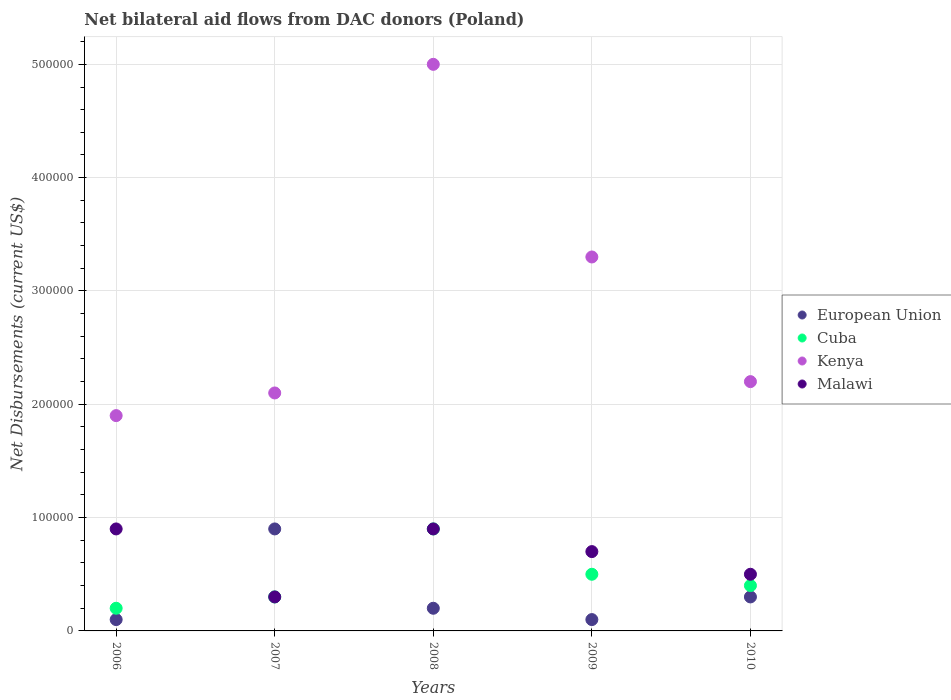Across all years, what is the maximum net bilateral aid flows in European Union?
Give a very brief answer. 9.00e+04. Across all years, what is the minimum net bilateral aid flows in Malawi?
Offer a terse response. 3.00e+04. What is the difference between the net bilateral aid flows in Malawi in 2007 and that in 2010?
Offer a very short reply. -2.00e+04. What is the difference between the net bilateral aid flows in European Union in 2007 and the net bilateral aid flows in Cuba in 2008?
Your answer should be compact. 0. What is the average net bilateral aid flows in European Union per year?
Keep it short and to the point. 3.20e+04. In how many years, is the net bilateral aid flows in Kenya greater than 40000 US$?
Your answer should be compact. 5. What is the ratio of the net bilateral aid flows in Kenya in 2007 to that in 2008?
Provide a succinct answer. 0.42. Is the net bilateral aid flows in Malawi in 2008 less than that in 2009?
Offer a terse response. No. What is the difference between the highest and the second highest net bilateral aid flows in Malawi?
Keep it short and to the point. 0. What is the difference between the highest and the lowest net bilateral aid flows in Malawi?
Provide a short and direct response. 6.00e+04. In how many years, is the net bilateral aid flows in European Union greater than the average net bilateral aid flows in European Union taken over all years?
Provide a short and direct response. 1. Does the net bilateral aid flows in Cuba monotonically increase over the years?
Provide a short and direct response. No. Is the net bilateral aid flows in Kenya strictly less than the net bilateral aid flows in Malawi over the years?
Provide a succinct answer. No. What is the difference between two consecutive major ticks on the Y-axis?
Keep it short and to the point. 1.00e+05. Does the graph contain any zero values?
Your response must be concise. No. How many legend labels are there?
Your answer should be compact. 4. How are the legend labels stacked?
Your response must be concise. Vertical. What is the title of the graph?
Offer a terse response. Net bilateral aid flows from DAC donors (Poland). Does "Hong Kong" appear as one of the legend labels in the graph?
Provide a succinct answer. No. What is the label or title of the X-axis?
Your answer should be compact. Years. What is the label or title of the Y-axis?
Offer a terse response. Net Disbursements (current US$). What is the Net Disbursements (current US$) in Cuba in 2006?
Offer a terse response. 2.00e+04. What is the Net Disbursements (current US$) of European Union in 2007?
Provide a short and direct response. 9.00e+04. What is the Net Disbursements (current US$) in Kenya in 2007?
Your response must be concise. 2.10e+05. What is the Net Disbursements (current US$) in European Union in 2008?
Your answer should be compact. 2.00e+04. What is the Net Disbursements (current US$) of Kenya in 2008?
Give a very brief answer. 5.00e+05. What is the Net Disbursements (current US$) of Malawi in 2008?
Provide a short and direct response. 9.00e+04. What is the Net Disbursements (current US$) in Cuba in 2009?
Offer a very short reply. 5.00e+04. What is the Net Disbursements (current US$) in Kenya in 2009?
Ensure brevity in your answer.  3.30e+05. What is the Net Disbursements (current US$) in Malawi in 2009?
Ensure brevity in your answer.  7.00e+04. What is the Net Disbursements (current US$) of Malawi in 2010?
Provide a succinct answer. 5.00e+04. Across all years, what is the maximum Net Disbursements (current US$) in European Union?
Your response must be concise. 9.00e+04. Across all years, what is the maximum Net Disbursements (current US$) in Cuba?
Offer a very short reply. 9.00e+04. Across all years, what is the maximum Net Disbursements (current US$) of Kenya?
Offer a terse response. 5.00e+05. Across all years, what is the minimum Net Disbursements (current US$) of European Union?
Keep it short and to the point. 10000. Across all years, what is the minimum Net Disbursements (current US$) in Cuba?
Ensure brevity in your answer.  2.00e+04. Across all years, what is the minimum Net Disbursements (current US$) in Kenya?
Your answer should be very brief. 1.90e+05. What is the total Net Disbursements (current US$) in Cuba in the graph?
Your answer should be very brief. 2.30e+05. What is the total Net Disbursements (current US$) of Kenya in the graph?
Offer a terse response. 1.45e+06. What is the total Net Disbursements (current US$) of Malawi in the graph?
Your answer should be compact. 3.30e+05. What is the difference between the Net Disbursements (current US$) in Cuba in 2006 and that in 2007?
Provide a short and direct response. -10000. What is the difference between the Net Disbursements (current US$) of Kenya in 2006 and that in 2007?
Your answer should be compact. -2.00e+04. What is the difference between the Net Disbursements (current US$) of Cuba in 2006 and that in 2008?
Provide a succinct answer. -7.00e+04. What is the difference between the Net Disbursements (current US$) in Kenya in 2006 and that in 2008?
Your response must be concise. -3.10e+05. What is the difference between the Net Disbursements (current US$) of Malawi in 2006 and that in 2008?
Provide a short and direct response. 0. What is the difference between the Net Disbursements (current US$) in European Union in 2006 and that in 2009?
Offer a terse response. 0. What is the difference between the Net Disbursements (current US$) in Cuba in 2006 and that in 2009?
Your answer should be very brief. -3.00e+04. What is the difference between the Net Disbursements (current US$) in Cuba in 2006 and that in 2010?
Make the answer very short. -2.00e+04. What is the difference between the Net Disbursements (current US$) of Cuba in 2007 and that in 2008?
Give a very brief answer. -6.00e+04. What is the difference between the Net Disbursements (current US$) of Malawi in 2007 and that in 2008?
Make the answer very short. -6.00e+04. What is the difference between the Net Disbursements (current US$) of European Union in 2007 and that in 2009?
Your answer should be compact. 8.00e+04. What is the difference between the Net Disbursements (current US$) of Cuba in 2007 and that in 2009?
Give a very brief answer. -2.00e+04. What is the difference between the Net Disbursements (current US$) in Malawi in 2007 and that in 2009?
Offer a very short reply. -4.00e+04. What is the difference between the Net Disbursements (current US$) in Kenya in 2007 and that in 2010?
Your answer should be very brief. -10000. What is the difference between the Net Disbursements (current US$) in Malawi in 2007 and that in 2010?
Your response must be concise. -2.00e+04. What is the difference between the Net Disbursements (current US$) of Cuba in 2008 and that in 2009?
Your answer should be very brief. 4.00e+04. What is the difference between the Net Disbursements (current US$) in Cuba in 2008 and that in 2010?
Make the answer very short. 5.00e+04. What is the difference between the Net Disbursements (current US$) of Cuba in 2009 and that in 2010?
Provide a short and direct response. 10000. What is the difference between the Net Disbursements (current US$) in Kenya in 2009 and that in 2010?
Offer a very short reply. 1.10e+05. What is the difference between the Net Disbursements (current US$) in European Union in 2006 and the Net Disbursements (current US$) in Kenya in 2007?
Your answer should be very brief. -2.00e+05. What is the difference between the Net Disbursements (current US$) of European Union in 2006 and the Net Disbursements (current US$) of Malawi in 2007?
Your answer should be compact. -2.00e+04. What is the difference between the Net Disbursements (current US$) of Cuba in 2006 and the Net Disbursements (current US$) of Kenya in 2007?
Make the answer very short. -1.90e+05. What is the difference between the Net Disbursements (current US$) of Kenya in 2006 and the Net Disbursements (current US$) of Malawi in 2007?
Your answer should be compact. 1.60e+05. What is the difference between the Net Disbursements (current US$) of European Union in 2006 and the Net Disbursements (current US$) of Kenya in 2008?
Provide a succinct answer. -4.90e+05. What is the difference between the Net Disbursements (current US$) in European Union in 2006 and the Net Disbursements (current US$) in Malawi in 2008?
Offer a very short reply. -8.00e+04. What is the difference between the Net Disbursements (current US$) in Cuba in 2006 and the Net Disbursements (current US$) in Kenya in 2008?
Make the answer very short. -4.80e+05. What is the difference between the Net Disbursements (current US$) in Kenya in 2006 and the Net Disbursements (current US$) in Malawi in 2008?
Ensure brevity in your answer.  1.00e+05. What is the difference between the Net Disbursements (current US$) of European Union in 2006 and the Net Disbursements (current US$) of Cuba in 2009?
Provide a succinct answer. -4.00e+04. What is the difference between the Net Disbursements (current US$) in European Union in 2006 and the Net Disbursements (current US$) in Kenya in 2009?
Your response must be concise. -3.20e+05. What is the difference between the Net Disbursements (current US$) in Cuba in 2006 and the Net Disbursements (current US$) in Kenya in 2009?
Ensure brevity in your answer.  -3.10e+05. What is the difference between the Net Disbursements (current US$) of Cuba in 2006 and the Net Disbursements (current US$) of Malawi in 2009?
Provide a succinct answer. -5.00e+04. What is the difference between the Net Disbursements (current US$) in Kenya in 2006 and the Net Disbursements (current US$) in Malawi in 2009?
Make the answer very short. 1.20e+05. What is the difference between the Net Disbursements (current US$) of European Union in 2006 and the Net Disbursements (current US$) of Cuba in 2010?
Give a very brief answer. -3.00e+04. What is the difference between the Net Disbursements (current US$) of European Union in 2006 and the Net Disbursements (current US$) of Kenya in 2010?
Give a very brief answer. -2.10e+05. What is the difference between the Net Disbursements (current US$) of Cuba in 2006 and the Net Disbursements (current US$) of Kenya in 2010?
Offer a very short reply. -2.00e+05. What is the difference between the Net Disbursements (current US$) of Cuba in 2006 and the Net Disbursements (current US$) of Malawi in 2010?
Keep it short and to the point. -3.00e+04. What is the difference between the Net Disbursements (current US$) of Kenya in 2006 and the Net Disbursements (current US$) of Malawi in 2010?
Provide a succinct answer. 1.40e+05. What is the difference between the Net Disbursements (current US$) in European Union in 2007 and the Net Disbursements (current US$) in Cuba in 2008?
Provide a short and direct response. 0. What is the difference between the Net Disbursements (current US$) in European Union in 2007 and the Net Disbursements (current US$) in Kenya in 2008?
Keep it short and to the point. -4.10e+05. What is the difference between the Net Disbursements (current US$) in Cuba in 2007 and the Net Disbursements (current US$) in Kenya in 2008?
Offer a very short reply. -4.70e+05. What is the difference between the Net Disbursements (current US$) in Cuba in 2007 and the Net Disbursements (current US$) in Malawi in 2008?
Keep it short and to the point. -6.00e+04. What is the difference between the Net Disbursements (current US$) of Kenya in 2007 and the Net Disbursements (current US$) of Malawi in 2008?
Keep it short and to the point. 1.20e+05. What is the difference between the Net Disbursements (current US$) in Cuba in 2007 and the Net Disbursements (current US$) in Malawi in 2009?
Your response must be concise. -4.00e+04. What is the difference between the Net Disbursements (current US$) in European Union in 2007 and the Net Disbursements (current US$) in Kenya in 2010?
Your answer should be very brief. -1.30e+05. What is the difference between the Net Disbursements (current US$) of Cuba in 2007 and the Net Disbursements (current US$) of Malawi in 2010?
Your answer should be compact. -2.00e+04. What is the difference between the Net Disbursements (current US$) in Kenya in 2007 and the Net Disbursements (current US$) in Malawi in 2010?
Your answer should be compact. 1.60e+05. What is the difference between the Net Disbursements (current US$) of European Union in 2008 and the Net Disbursements (current US$) of Kenya in 2009?
Make the answer very short. -3.10e+05. What is the difference between the Net Disbursements (current US$) of European Union in 2008 and the Net Disbursements (current US$) of Malawi in 2009?
Provide a succinct answer. -5.00e+04. What is the difference between the Net Disbursements (current US$) of Kenya in 2008 and the Net Disbursements (current US$) of Malawi in 2009?
Give a very brief answer. 4.30e+05. What is the difference between the Net Disbursements (current US$) of European Union in 2008 and the Net Disbursements (current US$) of Kenya in 2010?
Ensure brevity in your answer.  -2.00e+05. What is the difference between the Net Disbursements (current US$) in European Union in 2008 and the Net Disbursements (current US$) in Malawi in 2010?
Give a very brief answer. -3.00e+04. What is the difference between the Net Disbursements (current US$) in Cuba in 2008 and the Net Disbursements (current US$) in Malawi in 2010?
Give a very brief answer. 4.00e+04. What is the difference between the Net Disbursements (current US$) of European Union in 2009 and the Net Disbursements (current US$) of Cuba in 2010?
Your response must be concise. -3.00e+04. What is the difference between the Net Disbursements (current US$) in Cuba in 2009 and the Net Disbursements (current US$) in Malawi in 2010?
Your answer should be very brief. 0. What is the average Net Disbursements (current US$) of European Union per year?
Your answer should be very brief. 3.20e+04. What is the average Net Disbursements (current US$) of Cuba per year?
Make the answer very short. 4.60e+04. What is the average Net Disbursements (current US$) of Malawi per year?
Your response must be concise. 6.60e+04. In the year 2006, what is the difference between the Net Disbursements (current US$) of European Union and Net Disbursements (current US$) of Kenya?
Ensure brevity in your answer.  -1.80e+05. In the year 2006, what is the difference between the Net Disbursements (current US$) of European Union and Net Disbursements (current US$) of Malawi?
Ensure brevity in your answer.  -8.00e+04. In the year 2006, what is the difference between the Net Disbursements (current US$) in Kenya and Net Disbursements (current US$) in Malawi?
Your answer should be very brief. 1.00e+05. In the year 2007, what is the difference between the Net Disbursements (current US$) in European Union and Net Disbursements (current US$) in Kenya?
Offer a terse response. -1.20e+05. In the year 2007, what is the difference between the Net Disbursements (current US$) of Cuba and Net Disbursements (current US$) of Malawi?
Keep it short and to the point. 0. In the year 2008, what is the difference between the Net Disbursements (current US$) of European Union and Net Disbursements (current US$) of Cuba?
Provide a short and direct response. -7.00e+04. In the year 2008, what is the difference between the Net Disbursements (current US$) in European Union and Net Disbursements (current US$) in Kenya?
Provide a short and direct response. -4.80e+05. In the year 2008, what is the difference between the Net Disbursements (current US$) of European Union and Net Disbursements (current US$) of Malawi?
Give a very brief answer. -7.00e+04. In the year 2008, what is the difference between the Net Disbursements (current US$) in Cuba and Net Disbursements (current US$) in Kenya?
Your answer should be compact. -4.10e+05. In the year 2009, what is the difference between the Net Disbursements (current US$) in European Union and Net Disbursements (current US$) in Cuba?
Make the answer very short. -4.00e+04. In the year 2009, what is the difference between the Net Disbursements (current US$) of European Union and Net Disbursements (current US$) of Kenya?
Provide a short and direct response. -3.20e+05. In the year 2009, what is the difference between the Net Disbursements (current US$) of Cuba and Net Disbursements (current US$) of Kenya?
Provide a succinct answer. -2.80e+05. In the year 2009, what is the difference between the Net Disbursements (current US$) in Cuba and Net Disbursements (current US$) in Malawi?
Your answer should be very brief. -2.00e+04. In the year 2009, what is the difference between the Net Disbursements (current US$) of Kenya and Net Disbursements (current US$) of Malawi?
Ensure brevity in your answer.  2.60e+05. In the year 2010, what is the difference between the Net Disbursements (current US$) in European Union and Net Disbursements (current US$) in Kenya?
Your answer should be compact. -1.90e+05. What is the ratio of the Net Disbursements (current US$) in Cuba in 2006 to that in 2007?
Your answer should be very brief. 0.67. What is the ratio of the Net Disbursements (current US$) in Kenya in 2006 to that in 2007?
Offer a very short reply. 0.9. What is the ratio of the Net Disbursements (current US$) of Malawi in 2006 to that in 2007?
Your answer should be compact. 3. What is the ratio of the Net Disbursements (current US$) of Cuba in 2006 to that in 2008?
Provide a succinct answer. 0.22. What is the ratio of the Net Disbursements (current US$) of Kenya in 2006 to that in 2008?
Your answer should be compact. 0.38. What is the ratio of the Net Disbursements (current US$) of Malawi in 2006 to that in 2008?
Your answer should be very brief. 1. What is the ratio of the Net Disbursements (current US$) in Cuba in 2006 to that in 2009?
Your answer should be compact. 0.4. What is the ratio of the Net Disbursements (current US$) of Kenya in 2006 to that in 2009?
Your answer should be compact. 0.58. What is the ratio of the Net Disbursements (current US$) of Malawi in 2006 to that in 2009?
Make the answer very short. 1.29. What is the ratio of the Net Disbursements (current US$) of European Union in 2006 to that in 2010?
Your answer should be very brief. 0.33. What is the ratio of the Net Disbursements (current US$) of Cuba in 2006 to that in 2010?
Ensure brevity in your answer.  0.5. What is the ratio of the Net Disbursements (current US$) of Kenya in 2006 to that in 2010?
Give a very brief answer. 0.86. What is the ratio of the Net Disbursements (current US$) of Malawi in 2006 to that in 2010?
Your response must be concise. 1.8. What is the ratio of the Net Disbursements (current US$) of Cuba in 2007 to that in 2008?
Your answer should be very brief. 0.33. What is the ratio of the Net Disbursements (current US$) in Kenya in 2007 to that in 2008?
Keep it short and to the point. 0.42. What is the ratio of the Net Disbursements (current US$) of Malawi in 2007 to that in 2008?
Ensure brevity in your answer.  0.33. What is the ratio of the Net Disbursements (current US$) in Kenya in 2007 to that in 2009?
Offer a terse response. 0.64. What is the ratio of the Net Disbursements (current US$) in Malawi in 2007 to that in 2009?
Give a very brief answer. 0.43. What is the ratio of the Net Disbursements (current US$) in Cuba in 2007 to that in 2010?
Provide a short and direct response. 0.75. What is the ratio of the Net Disbursements (current US$) of Kenya in 2007 to that in 2010?
Ensure brevity in your answer.  0.95. What is the ratio of the Net Disbursements (current US$) in European Union in 2008 to that in 2009?
Provide a succinct answer. 2. What is the ratio of the Net Disbursements (current US$) in Kenya in 2008 to that in 2009?
Your answer should be very brief. 1.52. What is the ratio of the Net Disbursements (current US$) in European Union in 2008 to that in 2010?
Offer a terse response. 0.67. What is the ratio of the Net Disbursements (current US$) in Cuba in 2008 to that in 2010?
Your answer should be compact. 2.25. What is the ratio of the Net Disbursements (current US$) of Kenya in 2008 to that in 2010?
Your answer should be compact. 2.27. What is the ratio of the Net Disbursements (current US$) of Malawi in 2008 to that in 2010?
Offer a terse response. 1.8. What is the ratio of the Net Disbursements (current US$) in Cuba in 2009 to that in 2010?
Give a very brief answer. 1.25. What is the ratio of the Net Disbursements (current US$) in Malawi in 2009 to that in 2010?
Your answer should be very brief. 1.4. What is the difference between the highest and the second highest Net Disbursements (current US$) in Kenya?
Your answer should be compact. 1.70e+05. What is the difference between the highest and the lowest Net Disbursements (current US$) in Cuba?
Provide a short and direct response. 7.00e+04. What is the difference between the highest and the lowest Net Disbursements (current US$) in Malawi?
Give a very brief answer. 6.00e+04. 